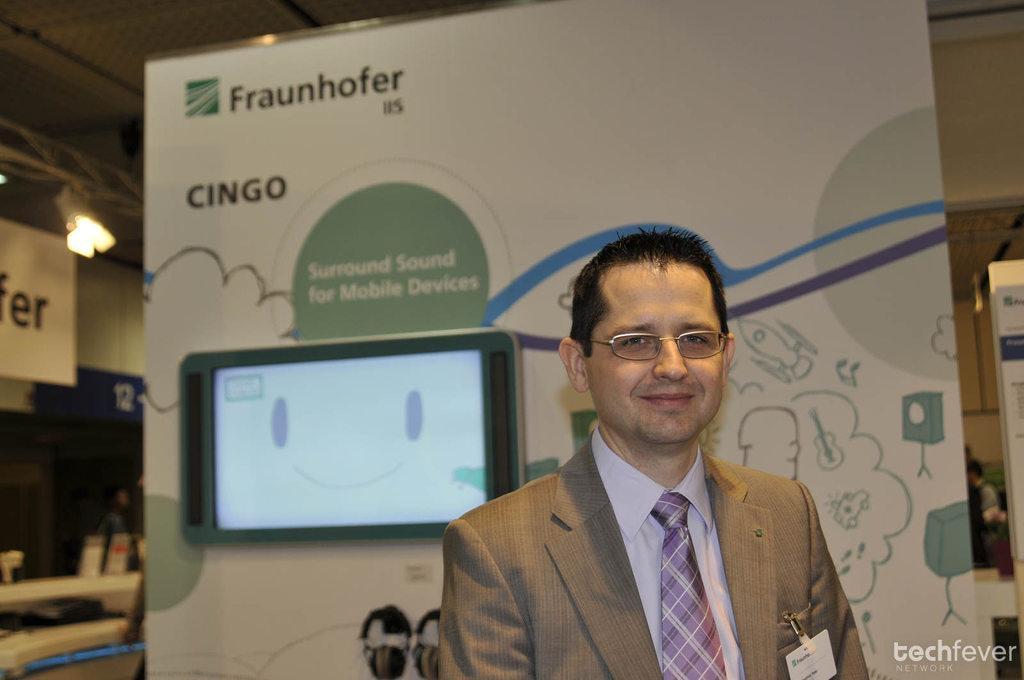Could you give a brief overview of what you see in this image? In the image we can see a man wearing clothes, spectacles and the man is smiling. Here we can see screen, poster and light. On the bottom right we can see the watermark. 